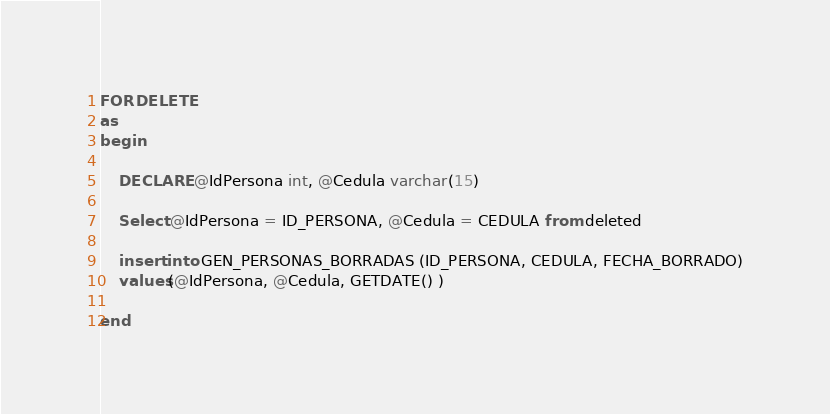Convert code to text. <code><loc_0><loc_0><loc_500><loc_500><_SQL_>FOR DELETE
as
begin
	
	DECLARE @IdPersona int, @Cedula varchar(15)

	Select @IdPersona = ID_PERSONA, @Cedula = CEDULA from deleted

	insert into GEN_PERSONAS_BORRADAS (ID_PERSONA, CEDULA, FECHA_BORRADO)
	values(@IdPersona, @Cedula, GETDATE() )

end</code> 